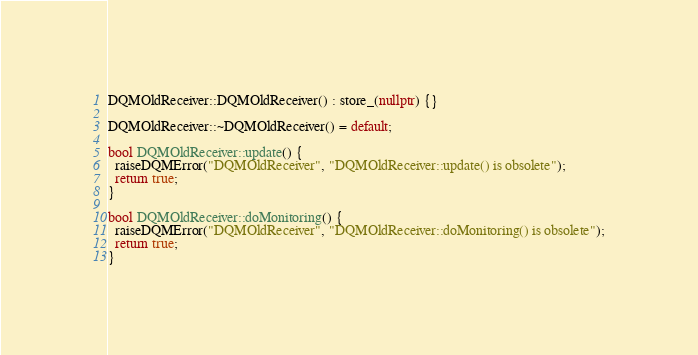<code> <loc_0><loc_0><loc_500><loc_500><_C++_>DQMOldReceiver::DQMOldReceiver() : store_(nullptr) {}

DQMOldReceiver::~DQMOldReceiver() = default;

bool DQMOldReceiver::update() {
  raiseDQMError("DQMOldReceiver", "DQMOldReceiver::update() is obsolete");
  return true;
}

bool DQMOldReceiver::doMonitoring() {
  raiseDQMError("DQMOldReceiver", "DQMOldReceiver::doMonitoring() is obsolete");
  return true;
}
</code> 